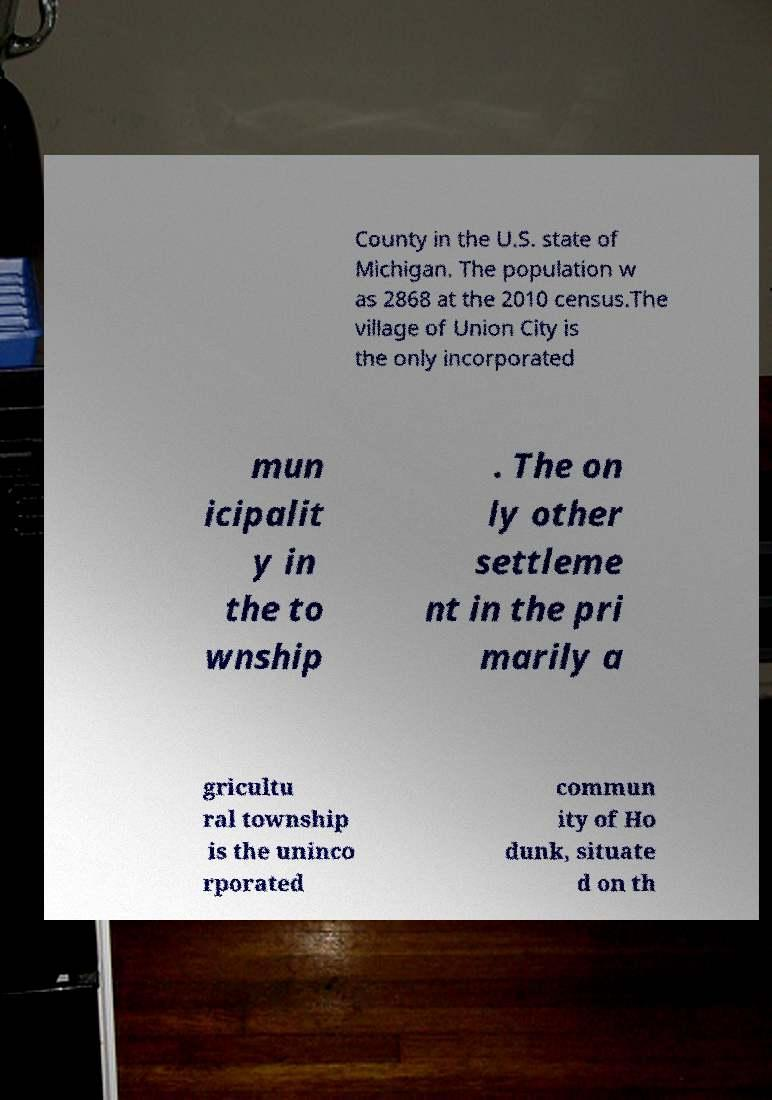There's text embedded in this image that I need extracted. Can you transcribe it verbatim? County in the U.S. state of Michigan. The population w as 2868 at the 2010 census.The village of Union City is the only incorporated mun icipalit y in the to wnship . The on ly other settleme nt in the pri marily a gricultu ral township is the uninco rporated commun ity of Ho dunk, situate d on th 